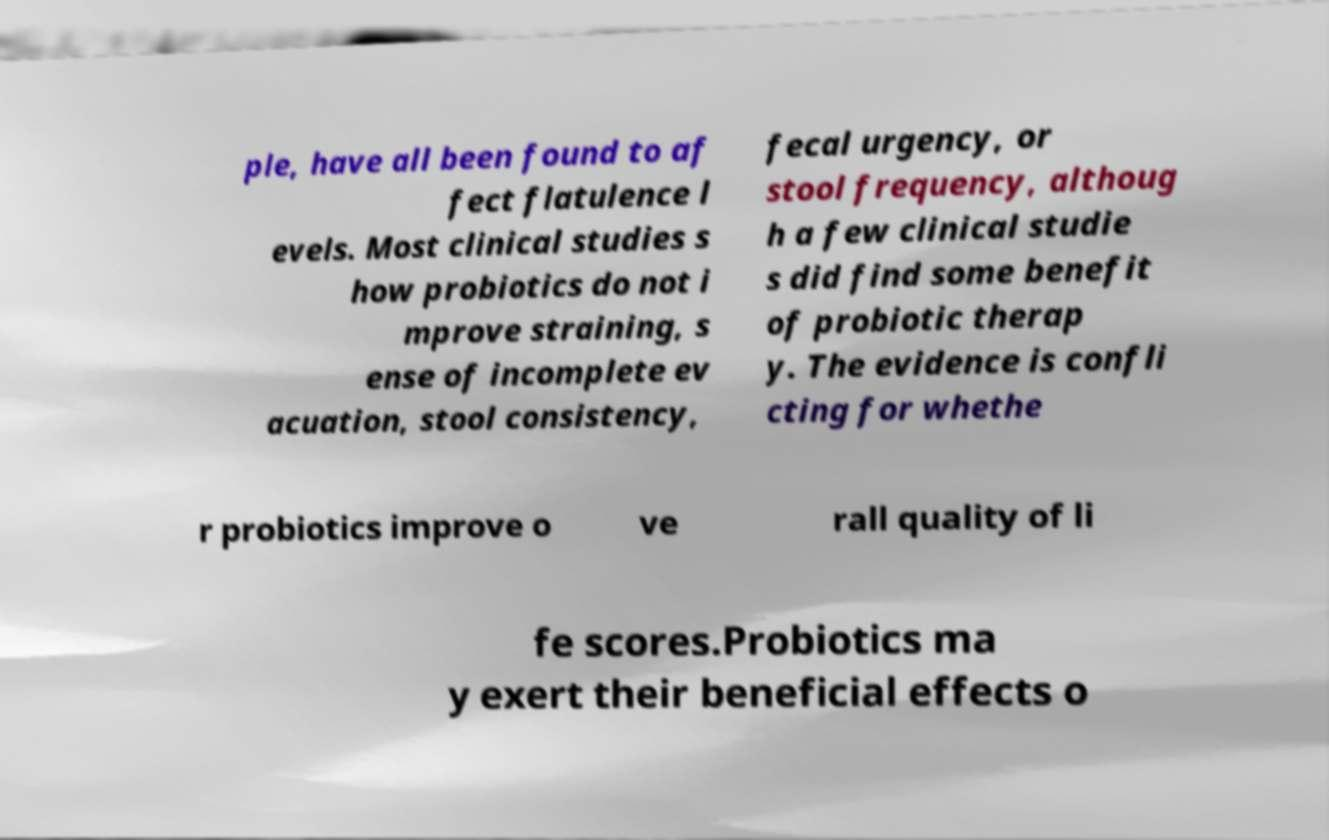I need the written content from this picture converted into text. Can you do that? ple, have all been found to af fect flatulence l evels. Most clinical studies s how probiotics do not i mprove straining, s ense of incomplete ev acuation, stool consistency, fecal urgency, or stool frequency, althoug h a few clinical studie s did find some benefit of probiotic therap y. The evidence is confli cting for whethe r probiotics improve o ve rall quality of li fe scores.Probiotics ma y exert their beneficial effects o 